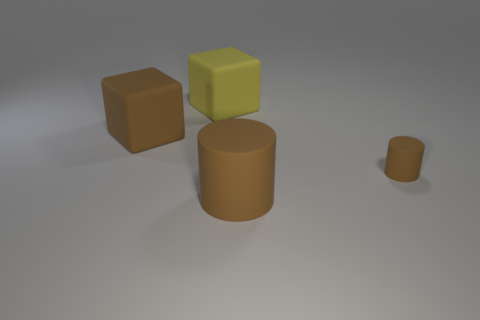Subtract all yellow cubes. How many cubes are left? 1 Add 4 small gray metal cylinders. How many objects exist? 8 Add 3 big matte cylinders. How many big matte cylinders are left? 4 Add 4 small brown rubber cylinders. How many small brown rubber cylinders exist? 5 Subtract 0 cyan cylinders. How many objects are left? 4 Subtract all yellow blocks. Subtract all cyan spheres. How many blocks are left? 1 Subtract all red spheres. How many yellow blocks are left? 1 Subtract all brown metallic cylinders. Subtract all cubes. How many objects are left? 2 